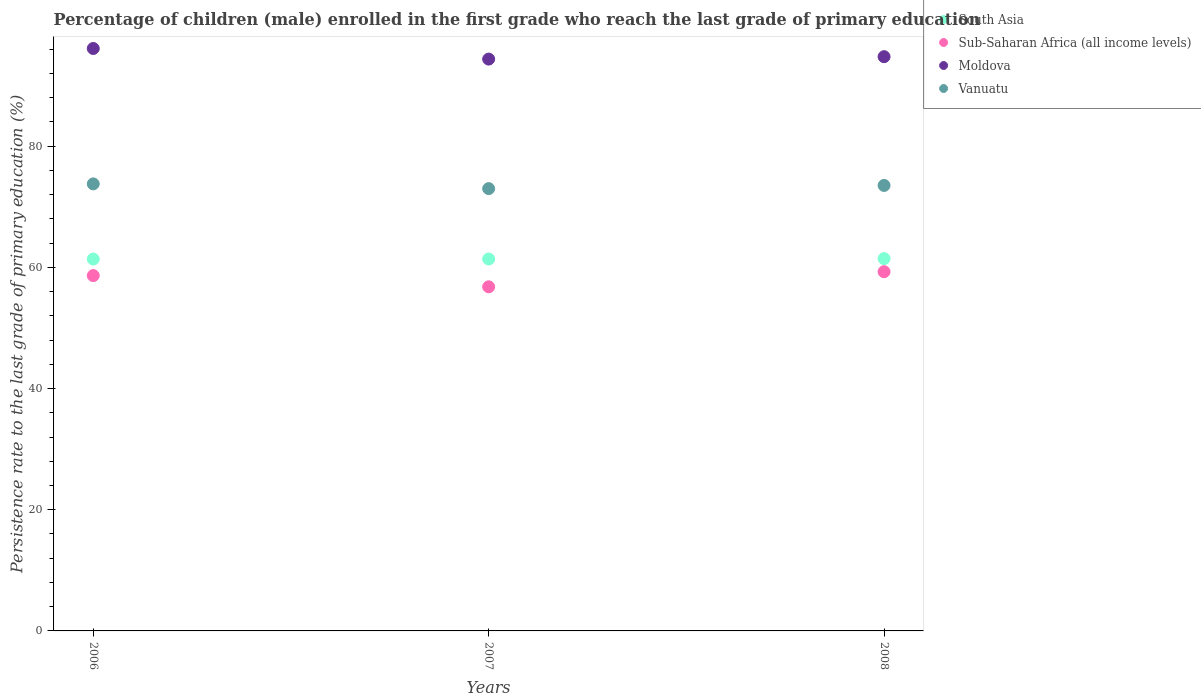How many different coloured dotlines are there?
Your answer should be very brief. 4. Is the number of dotlines equal to the number of legend labels?
Your answer should be compact. Yes. What is the persistence rate of children in South Asia in 2006?
Offer a very short reply. 61.38. Across all years, what is the maximum persistence rate of children in Moldova?
Offer a very short reply. 96.13. Across all years, what is the minimum persistence rate of children in Sub-Saharan Africa (all income levels)?
Offer a terse response. 56.8. In which year was the persistence rate of children in Sub-Saharan Africa (all income levels) maximum?
Your answer should be compact. 2008. What is the total persistence rate of children in Moldova in the graph?
Offer a very short reply. 285.29. What is the difference between the persistence rate of children in Vanuatu in 2006 and that in 2008?
Give a very brief answer. 0.25. What is the difference between the persistence rate of children in South Asia in 2007 and the persistence rate of children in Moldova in 2008?
Your response must be concise. -33.4. What is the average persistence rate of children in South Asia per year?
Your answer should be compact. 61.41. In the year 2008, what is the difference between the persistence rate of children in Sub-Saharan Africa (all income levels) and persistence rate of children in Moldova?
Your answer should be compact. -35.49. What is the ratio of the persistence rate of children in Vanuatu in 2007 to that in 2008?
Provide a succinct answer. 0.99. Is the persistence rate of children in Vanuatu in 2006 less than that in 2008?
Ensure brevity in your answer.  No. What is the difference between the highest and the second highest persistence rate of children in Sub-Saharan Africa (all income levels)?
Your answer should be compact. 0.64. What is the difference between the highest and the lowest persistence rate of children in Vanuatu?
Offer a terse response. 0.78. Is the sum of the persistence rate of children in Moldova in 2006 and 2007 greater than the maximum persistence rate of children in Vanuatu across all years?
Provide a short and direct response. Yes. Is it the case that in every year, the sum of the persistence rate of children in Moldova and persistence rate of children in South Asia  is greater than the sum of persistence rate of children in Vanuatu and persistence rate of children in Sub-Saharan Africa (all income levels)?
Provide a short and direct response. No. Is the persistence rate of children in South Asia strictly greater than the persistence rate of children in Moldova over the years?
Your answer should be compact. No. How many dotlines are there?
Provide a succinct answer. 4. How many years are there in the graph?
Your answer should be compact. 3. What is the difference between two consecutive major ticks on the Y-axis?
Your response must be concise. 20. Are the values on the major ticks of Y-axis written in scientific E-notation?
Offer a very short reply. No. How are the legend labels stacked?
Your response must be concise. Vertical. What is the title of the graph?
Offer a very short reply. Percentage of children (male) enrolled in the first grade who reach the last grade of primary education. What is the label or title of the Y-axis?
Ensure brevity in your answer.  Persistence rate to the last grade of primary education (%). What is the Persistence rate to the last grade of primary education (%) of South Asia in 2006?
Provide a short and direct response. 61.38. What is the Persistence rate to the last grade of primary education (%) in Sub-Saharan Africa (all income levels) in 2006?
Keep it short and to the point. 58.65. What is the Persistence rate to the last grade of primary education (%) in Moldova in 2006?
Provide a succinct answer. 96.13. What is the Persistence rate to the last grade of primary education (%) of Vanuatu in 2006?
Offer a terse response. 73.78. What is the Persistence rate to the last grade of primary education (%) of South Asia in 2007?
Offer a very short reply. 61.38. What is the Persistence rate to the last grade of primary education (%) of Sub-Saharan Africa (all income levels) in 2007?
Provide a succinct answer. 56.8. What is the Persistence rate to the last grade of primary education (%) of Moldova in 2007?
Provide a succinct answer. 94.38. What is the Persistence rate to the last grade of primary education (%) of Vanuatu in 2007?
Provide a short and direct response. 73. What is the Persistence rate to the last grade of primary education (%) of South Asia in 2008?
Give a very brief answer. 61.45. What is the Persistence rate to the last grade of primary education (%) of Sub-Saharan Africa (all income levels) in 2008?
Your answer should be compact. 59.29. What is the Persistence rate to the last grade of primary education (%) in Moldova in 2008?
Keep it short and to the point. 94.78. What is the Persistence rate to the last grade of primary education (%) of Vanuatu in 2008?
Provide a short and direct response. 73.53. Across all years, what is the maximum Persistence rate to the last grade of primary education (%) of South Asia?
Make the answer very short. 61.45. Across all years, what is the maximum Persistence rate to the last grade of primary education (%) of Sub-Saharan Africa (all income levels)?
Provide a short and direct response. 59.29. Across all years, what is the maximum Persistence rate to the last grade of primary education (%) of Moldova?
Provide a succinct answer. 96.13. Across all years, what is the maximum Persistence rate to the last grade of primary education (%) in Vanuatu?
Offer a terse response. 73.78. Across all years, what is the minimum Persistence rate to the last grade of primary education (%) of South Asia?
Provide a succinct answer. 61.38. Across all years, what is the minimum Persistence rate to the last grade of primary education (%) in Sub-Saharan Africa (all income levels)?
Your answer should be very brief. 56.8. Across all years, what is the minimum Persistence rate to the last grade of primary education (%) of Moldova?
Your answer should be very brief. 94.38. Across all years, what is the minimum Persistence rate to the last grade of primary education (%) of Vanuatu?
Offer a terse response. 73. What is the total Persistence rate to the last grade of primary education (%) of South Asia in the graph?
Provide a short and direct response. 184.22. What is the total Persistence rate to the last grade of primary education (%) in Sub-Saharan Africa (all income levels) in the graph?
Offer a terse response. 174.73. What is the total Persistence rate to the last grade of primary education (%) in Moldova in the graph?
Keep it short and to the point. 285.29. What is the total Persistence rate to the last grade of primary education (%) of Vanuatu in the graph?
Ensure brevity in your answer.  220.31. What is the difference between the Persistence rate to the last grade of primary education (%) of South Asia in 2006 and that in 2007?
Provide a succinct answer. -0. What is the difference between the Persistence rate to the last grade of primary education (%) in Sub-Saharan Africa (all income levels) in 2006 and that in 2007?
Your answer should be very brief. 1.85. What is the difference between the Persistence rate to the last grade of primary education (%) in Moldova in 2006 and that in 2007?
Your answer should be compact. 1.75. What is the difference between the Persistence rate to the last grade of primary education (%) in Vanuatu in 2006 and that in 2007?
Make the answer very short. 0.78. What is the difference between the Persistence rate to the last grade of primary education (%) of South Asia in 2006 and that in 2008?
Keep it short and to the point. -0.07. What is the difference between the Persistence rate to the last grade of primary education (%) in Sub-Saharan Africa (all income levels) in 2006 and that in 2008?
Offer a very short reply. -0.64. What is the difference between the Persistence rate to the last grade of primary education (%) of Moldova in 2006 and that in 2008?
Ensure brevity in your answer.  1.35. What is the difference between the Persistence rate to the last grade of primary education (%) in Vanuatu in 2006 and that in 2008?
Your answer should be compact. 0.25. What is the difference between the Persistence rate to the last grade of primary education (%) in South Asia in 2007 and that in 2008?
Provide a short and direct response. -0.07. What is the difference between the Persistence rate to the last grade of primary education (%) in Sub-Saharan Africa (all income levels) in 2007 and that in 2008?
Provide a short and direct response. -2.5. What is the difference between the Persistence rate to the last grade of primary education (%) in Moldova in 2007 and that in 2008?
Your answer should be very brief. -0.4. What is the difference between the Persistence rate to the last grade of primary education (%) of Vanuatu in 2007 and that in 2008?
Make the answer very short. -0.53. What is the difference between the Persistence rate to the last grade of primary education (%) in South Asia in 2006 and the Persistence rate to the last grade of primary education (%) in Sub-Saharan Africa (all income levels) in 2007?
Give a very brief answer. 4.58. What is the difference between the Persistence rate to the last grade of primary education (%) of South Asia in 2006 and the Persistence rate to the last grade of primary education (%) of Moldova in 2007?
Your answer should be compact. -33. What is the difference between the Persistence rate to the last grade of primary education (%) in South Asia in 2006 and the Persistence rate to the last grade of primary education (%) in Vanuatu in 2007?
Offer a very short reply. -11.62. What is the difference between the Persistence rate to the last grade of primary education (%) in Sub-Saharan Africa (all income levels) in 2006 and the Persistence rate to the last grade of primary education (%) in Moldova in 2007?
Make the answer very short. -35.73. What is the difference between the Persistence rate to the last grade of primary education (%) in Sub-Saharan Africa (all income levels) in 2006 and the Persistence rate to the last grade of primary education (%) in Vanuatu in 2007?
Your response must be concise. -14.35. What is the difference between the Persistence rate to the last grade of primary education (%) in Moldova in 2006 and the Persistence rate to the last grade of primary education (%) in Vanuatu in 2007?
Your answer should be compact. 23.13. What is the difference between the Persistence rate to the last grade of primary education (%) of South Asia in 2006 and the Persistence rate to the last grade of primary education (%) of Sub-Saharan Africa (all income levels) in 2008?
Offer a terse response. 2.09. What is the difference between the Persistence rate to the last grade of primary education (%) in South Asia in 2006 and the Persistence rate to the last grade of primary education (%) in Moldova in 2008?
Provide a short and direct response. -33.4. What is the difference between the Persistence rate to the last grade of primary education (%) of South Asia in 2006 and the Persistence rate to the last grade of primary education (%) of Vanuatu in 2008?
Provide a short and direct response. -12.15. What is the difference between the Persistence rate to the last grade of primary education (%) in Sub-Saharan Africa (all income levels) in 2006 and the Persistence rate to the last grade of primary education (%) in Moldova in 2008?
Your answer should be very brief. -36.13. What is the difference between the Persistence rate to the last grade of primary education (%) in Sub-Saharan Africa (all income levels) in 2006 and the Persistence rate to the last grade of primary education (%) in Vanuatu in 2008?
Ensure brevity in your answer.  -14.88. What is the difference between the Persistence rate to the last grade of primary education (%) of Moldova in 2006 and the Persistence rate to the last grade of primary education (%) of Vanuatu in 2008?
Offer a very short reply. 22.6. What is the difference between the Persistence rate to the last grade of primary education (%) in South Asia in 2007 and the Persistence rate to the last grade of primary education (%) in Sub-Saharan Africa (all income levels) in 2008?
Keep it short and to the point. 2.09. What is the difference between the Persistence rate to the last grade of primary education (%) of South Asia in 2007 and the Persistence rate to the last grade of primary education (%) of Moldova in 2008?
Keep it short and to the point. -33.4. What is the difference between the Persistence rate to the last grade of primary education (%) in South Asia in 2007 and the Persistence rate to the last grade of primary education (%) in Vanuatu in 2008?
Your answer should be very brief. -12.14. What is the difference between the Persistence rate to the last grade of primary education (%) of Sub-Saharan Africa (all income levels) in 2007 and the Persistence rate to the last grade of primary education (%) of Moldova in 2008?
Provide a succinct answer. -37.98. What is the difference between the Persistence rate to the last grade of primary education (%) in Sub-Saharan Africa (all income levels) in 2007 and the Persistence rate to the last grade of primary education (%) in Vanuatu in 2008?
Ensure brevity in your answer.  -16.73. What is the difference between the Persistence rate to the last grade of primary education (%) of Moldova in 2007 and the Persistence rate to the last grade of primary education (%) of Vanuatu in 2008?
Your answer should be very brief. 20.85. What is the average Persistence rate to the last grade of primary education (%) of South Asia per year?
Offer a terse response. 61.41. What is the average Persistence rate to the last grade of primary education (%) of Sub-Saharan Africa (all income levels) per year?
Make the answer very short. 58.24. What is the average Persistence rate to the last grade of primary education (%) in Moldova per year?
Your response must be concise. 95.1. What is the average Persistence rate to the last grade of primary education (%) of Vanuatu per year?
Your answer should be compact. 73.44. In the year 2006, what is the difference between the Persistence rate to the last grade of primary education (%) of South Asia and Persistence rate to the last grade of primary education (%) of Sub-Saharan Africa (all income levels)?
Give a very brief answer. 2.73. In the year 2006, what is the difference between the Persistence rate to the last grade of primary education (%) in South Asia and Persistence rate to the last grade of primary education (%) in Moldova?
Your response must be concise. -34.75. In the year 2006, what is the difference between the Persistence rate to the last grade of primary education (%) of South Asia and Persistence rate to the last grade of primary education (%) of Vanuatu?
Your answer should be very brief. -12.4. In the year 2006, what is the difference between the Persistence rate to the last grade of primary education (%) of Sub-Saharan Africa (all income levels) and Persistence rate to the last grade of primary education (%) of Moldova?
Your answer should be very brief. -37.48. In the year 2006, what is the difference between the Persistence rate to the last grade of primary education (%) of Sub-Saharan Africa (all income levels) and Persistence rate to the last grade of primary education (%) of Vanuatu?
Make the answer very short. -15.13. In the year 2006, what is the difference between the Persistence rate to the last grade of primary education (%) in Moldova and Persistence rate to the last grade of primary education (%) in Vanuatu?
Ensure brevity in your answer.  22.35. In the year 2007, what is the difference between the Persistence rate to the last grade of primary education (%) of South Asia and Persistence rate to the last grade of primary education (%) of Sub-Saharan Africa (all income levels)?
Provide a short and direct response. 4.59. In the year 2007, what is the difference between the Persistence rate to the last grade of primary education (%) of South Asia and Persistence rate to the last grade of primary education (%) of Moldova?
Make the answer very short. -32.99. In the year 2007, what is the difference between the Persistence rate to the last grade of primary education (%) in South Asia and Persistence rate to the last grade of primary education (%) in Vanuatu?
Your answer should be compact. -11.62. In the year 2007, what is the difference between the Persistence rate to the last grade of primary education (%) of Sub-Saharan Africa (all income levels) and Persistence rate to the last grade of primary education (%) of Moldova?
Offer a terse response. -37.58. In the year 2007, what is the difference between the Persistence rate to the last grade of primary education (%) in Sub-Saharan Africa (all income levels) and Persistence rate to the last grade of primary education (%) in Vanuatu?
Give a very brief answer. -16.21. In the year 2007, what is the difference between the Persistence rate to the last grade of primary education (%) in Moldova and Persistence rate to the last grade of primary education (%) in Vanuatu?
Provide a succinct answer. 21.38. In the year 2008, what is the difference between the Persistence rate to the last grade of primary education (%) of South Asia and Persistence rate to the last grade of primary education (%) of Sub-Saharan Africa (all income levels)?
Offer a very short reply. 2.16. In the year 2008, what is the difference between the Persistence rate to the last grade of primary education (%) of South Asia and Persistence rate to the last grade of primary education (%) of Moldova?
Your answer should be very brief. -33.33. In the year 2008, what is the difference between the Persistence rate to the last grade of primary education (%) of South Asia and Persistence rate to the last grade of primary education (%) of Vanuatu?
Offer a terse response. -12.08. In the year 2008, what is the difference between the Persistence rate to the last grade of primary education (%) of Sub-Saharan Africa (all income levels) and Persistence rate to the last grade of primary education (%) of Moldova?
Your response must be concise. -35.49. In the year 2008, what is the difference between the Persistence rate to the last grade of primary education (%) of Sub-Saharan Africa (all income levels) and Persistence rate to the last grade of primary education (%) of Vanuatu?
Offer a very short reply. -14.24. In the year 2008, what is the difference between the Persistence rate to the last grade of primary education (%) of Moldova and Persistence rate to the last grade of primary education (%) of Vanuatu?
Your answer should be compact. 21.25. What is the ratio of the Persistence rate to the last grade of primary education (%) in Sub-Saharan Africa (all income levels) in 2006 to that in 2007?
Offer a very short reply. 1.03. What is the ratio of the Persistence rate to the last grade of primary education (%) in Moldova in 2006 to that in 2007?
Offer a terse response. 1.02. What is the ratio of the Persistence rate to the last grade of primary education (%) of Vanuatu in 2006 to that in 2007?
Make the answer very short. 1.01. What is the ratio of the Persistence rate to the last grade of primary education (%) of Sub-Saharan Africa (all income levels) in 2006 to that in 2008?
Give a very brief answer. 0.99. What is the ratio of the Persistence rate to the last grade of primary education (%) in Moldova in 2006 to that in 2008?
Make the answer very short. 1.01. What is the ratio of the Persistence rate to the last grade of primary education (%) of Sub-Saharan Africa (all income levels) in 2007 to that in 2008?
Give a very brief answer. 0.96. What is the ratio of the Persistence rate to the last grade of primary education (%) in Moldova in 2007 to that in 2008?
Offer a terse response. 1. What is the ratio of the Persistence rate to the last grade of primary education (%) of Vanuatu in 2007 to that in 2008?
Offer a very short reply. 0.99. What is the difference between the highest and the second highest Persistence rate to the last grade of primary education (%) in South Asia?
Offer a very short reply. 0.07. What is the difference between the highest and the second highest Persistence rate to the last grade of primary education (%) in Sub-Saharan Africa (all income levels)?
Provide a succinct answer. 0.64. What is the difference between the highest and the second highest Persistence rate to the last grade of primary education (%) in Moldova?
Ensure brevity in your answer.  1.35. What is the difference between the highest and the second highest Persistence rate to the last grade of primary education (%) of Vanuatu?
Your answer should be compact. 0.25. What is the difference between the highest and the lowest Persistence rate to the last grade of primary education (%) of South Asia?
Your response must be concise. 0.07. What is the difference between the highest and the lowest Persistence rate to the last grade of primary education (%) in Sub-Saharan Africa (all income levels)?
Your response must be concise. 2.5. What is the difference between the highest and the lowest Persistence rate to the last grade of primary education (%) in Moldova?
Provide a short and direct response. 1.75. What is the difference between the highest and the lowest Persistence rate to the last grade of primary education (%) in Vanuatu?
Keep it short and to the point. 0.78. 